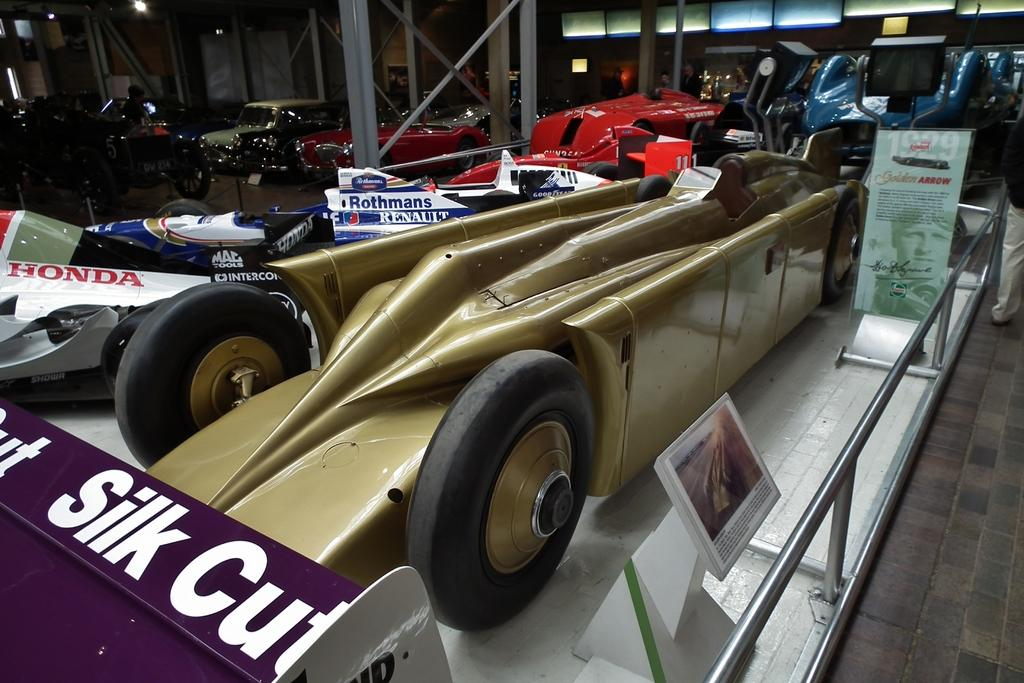What types of vehicles are in the image? There are vehicles in the image, but the specific types cannot be determined from the provided facts. What are the boards used for in the image? The purpose of the boards in the image cannot be determined from the provided facts. What is the railing used for in the image? The railing is likely used for safety or support, but the specific purpose cannot be determined from the provided facts. What is the floor made of in the image? The material of the floor cannot be determined from the provided facts. What are the rods used for in the image? The purpose of the rods in the image cannot be determined from the provided facts. What types of objects are in the image? There are objects in the image, but their specific types cannot be determined from the provided facts. What is visible in the background of the image? In the background of the image, there is a wall, lights, and other objects. However, the specific types of objects cannot be determined from the provided facts. How many fingers does the person in the image have? There is no mention of a person in the image, so it is impossible to determine the number of fingers they have. What type of work is being done in the image? There is no indication of any work being done in the image, so it is impossible to determine the type of work being done. 